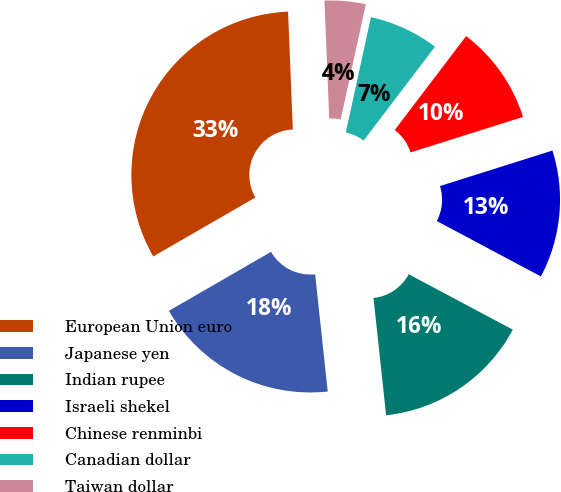<chart> <loc_0><loc_0><loc_500><loc_500><pie_chart><fcel>European Union euro<fcel>Japanese yen<fcel>Indian rupee<fcel>Israeli shekel<fcel>Chinese renminbi<fcel>Canadian dollar<fcel>Taiwan dollar<nl><fcel>32.69%<fcel>18.37%<fcel>15.51%<fcel>12.65%<fcel>9.79%<fcel>6.93%<fcel>4.06%<nl></chart> 